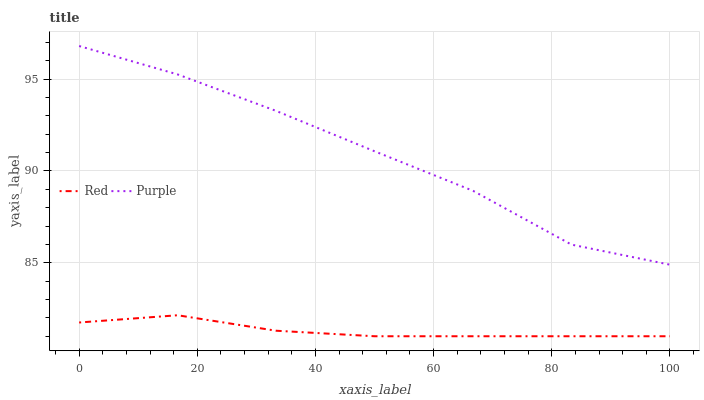Does Red have the minimum area under the curve?
Answer yes or no. Yes. Does Purple have the maximum area under the curve?
Answer yes or no. Yes. Does Red have the maximum area under the curve?
Answer yes or no. No. Is Red the smoothest?
Answer yes or no. Yes. Is Purple the roughest?
Answer yes or no. Yes. Is Red the roughest?
Answer yes or no. No. Does Red have the lowest value?
Answer yes or no. Yes. Does Purple have the highest value?
Answer yes or no. Yes. Does Red have the highest value?
Answer yes or no. No. Is Red less than Purple?
Answer yes or no. Yes. Is Purple greater than Red?
Answer yes or no. Yes. Does Red intersect Purple?
Answer yes or no. No. 